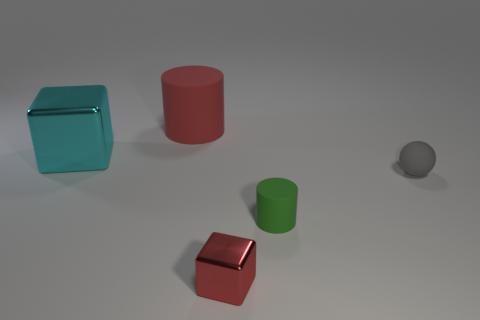Subtract all red cylinders. How many cylinders are left? 1 Add 4 metallic things. How many objects exist? 9 Subtract all balls. How many objects are left? 4 Subtract 1 cubes. How many cubes are left? 1 Add 4 small gray balls. How many small gray balls are left? 5 Add 4 matte spheres. How many matte spheres exist? 5 Subtract 0 purple cylinders. How many objects are left? 5 Subtract all yellow balls. Subtract all red cylinders. How many balls are left? 1 Subtract all gray spheres. Subtract all small green matte objects. How many objects are left? 3 